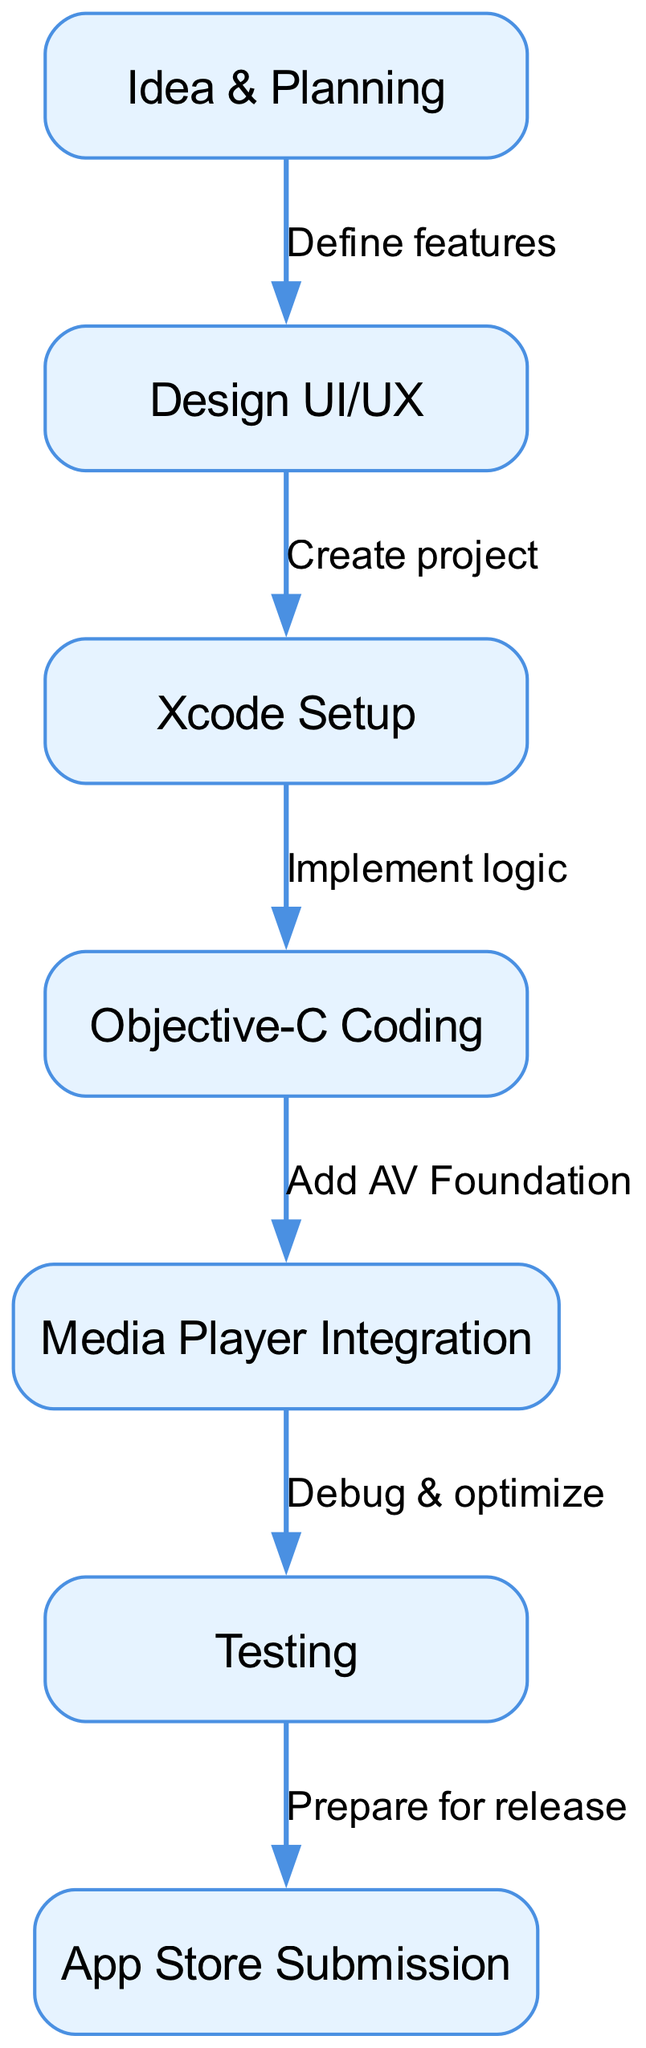What is the first step in the iOS app development lifecycle? The first step in the diagram is labeled "Idea & Planning," indicating it is the initial phase of the development process.
Answer: Idea & Planning How many nodes are present in the diagram? The diagram contains seven nodes: Idea & Planning, Design UI/UX, Xcode Setup, Objective-C Coding, Media Player Integration, Testing, and App Store Submission. Counting these gives a total of seven nodes.
Answer: 7 What is the relationship between "Design UI/UX" and "Xcode Setup"? The relationship is defined by the edge labeled "Create project," which connects the two nodes, indicating that after designing UI/UX, the next step is setting up the project in Xcode.
Answer: Create project Which step comes directly after "Media Player Integration"? According to the flow in the diagram, "Testing" comes directly after "Media Player Integration," as shown by the connected edge that flows from Media Player Integration to Testing.
Answer: Testing What is the final step in the development lifecycle? The final step in the diagram is labeled "App Store Submission," which is the last point in the app development process showing it is ready for release.
Answer: App Store Submission Which two nodes are connected by the edge labeled "Prepare for release"? The edge labeled "Prepare for release" connects "Testing" and "App Store Submission," indicating that preparation for release occurs after testing the app.
Answer: Testing and App Store Submission What happens after "Objective-C Coding"? After "Objective-C Coding," the next step is "Media Player Integration," which is indicated by the edge labeled "Add AV Foundation." This means that after coding, the media player features are integrated next.
Answer: Media Player Integration How does "Idea & Planning" influence the subsequent steps? "Idea & Planning" leads to "Design UI/UX," which defines the features for the app, guiding the subsequent steps of design, development, and integration in the lifecycle.
Answer: Design UI/UX What is the purpose of the node "Testing"? The purpose of the "Testing" node is to perform debugging and optimization of the application, as indicated by the edge that leads from "Media Player Integration" to "Testing."
Answer: Debug & optimize 